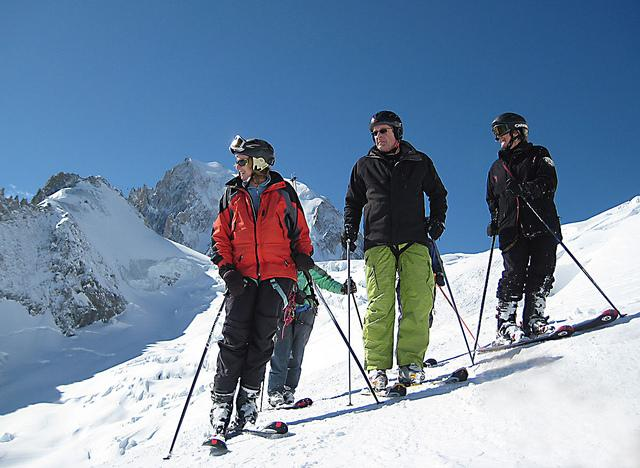What are they ready to do here? Please explain your reasoning. descend. Once a skier is at the top of the mountain, there is nothing else to do but ski down. 